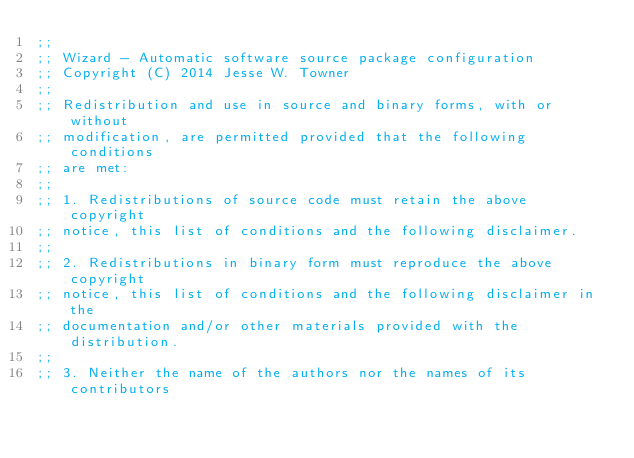Convert code to text. <code><loc_0><loc_0><loc_500><loc_500><_Scheme_>;;
;; Wizard - Automatic software source package configuration
;; Copyright (C) 2014 Jesse W. Towner
;;
;; Redistribution and use in source and binary forms, with or without
;; modification, are permitted provided that the following conditions
;; are met:
;;
;; 1. Redistributions of source code must retain the above copyright
;; notice, this list of conditions and the following disclaimer.
;;
;; 2. Redistributions in binary form must reproduce the above copyright
;; notice, this list of conditions and the following disclaimer in the
;; documentation and/or other materials provided with the distribution.
;;
;; 3. Neither the name of the authors nor the names of its contributors</code> 